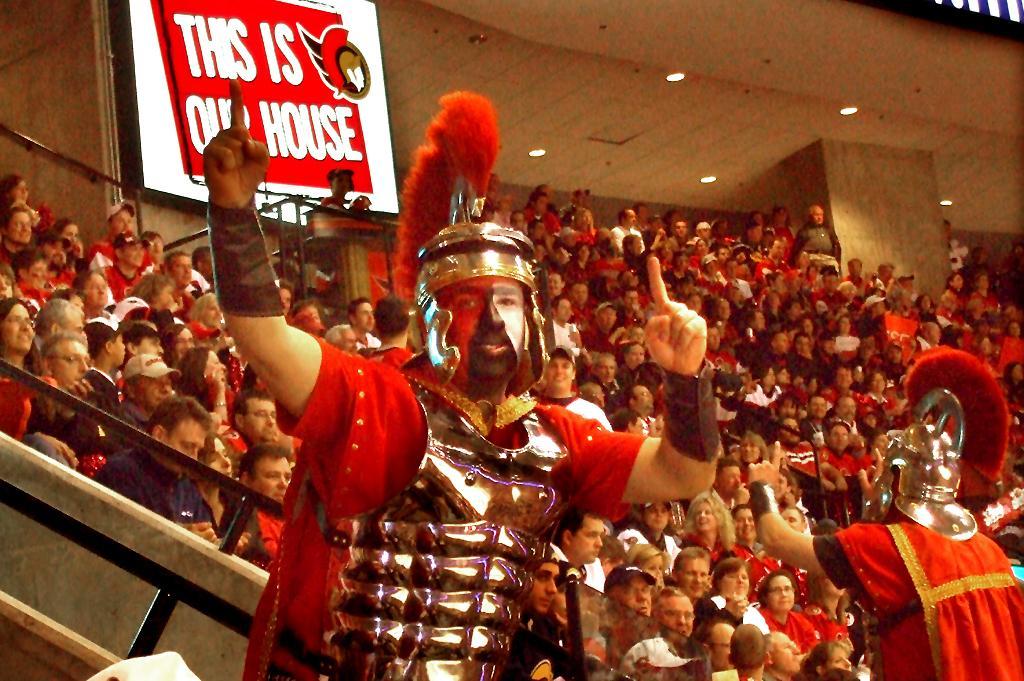Please provide a concise description of this image. In this image, we can see some people sitting, at the middle there is a person standing. 